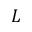Convert formula to latex. <formula><loc_0><loc_0><loc_500><loc_500>L</formula> 